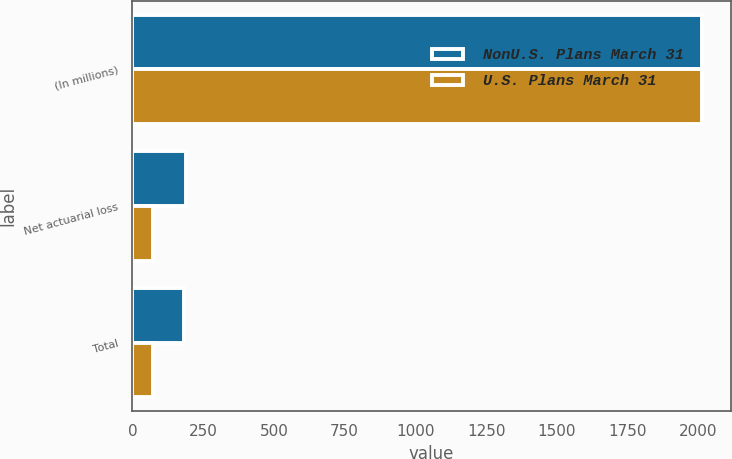<chart> <loc_0><loc_0><loc_500><loc_500><stacked_bar_chart><ecel><fcel>(In millions)<fcel>Net actuarial loss<fcel>Total<nl><fcel>NonU.S. Plans March 31<fcel>2014<fcel>188<fcel>181<nl><fcel>U.S. Plans March 31<fcel>2014<fcel>71<fcel>71<nl></chart> 